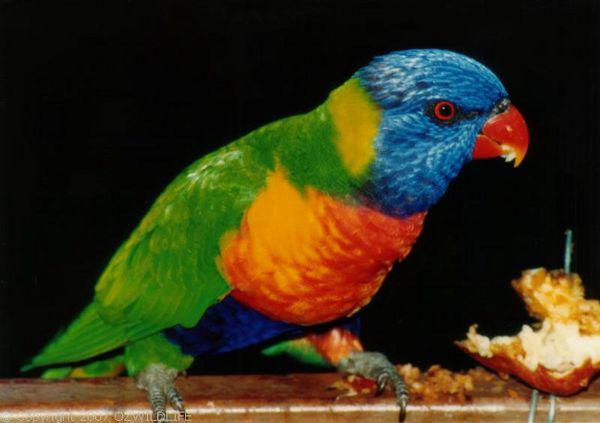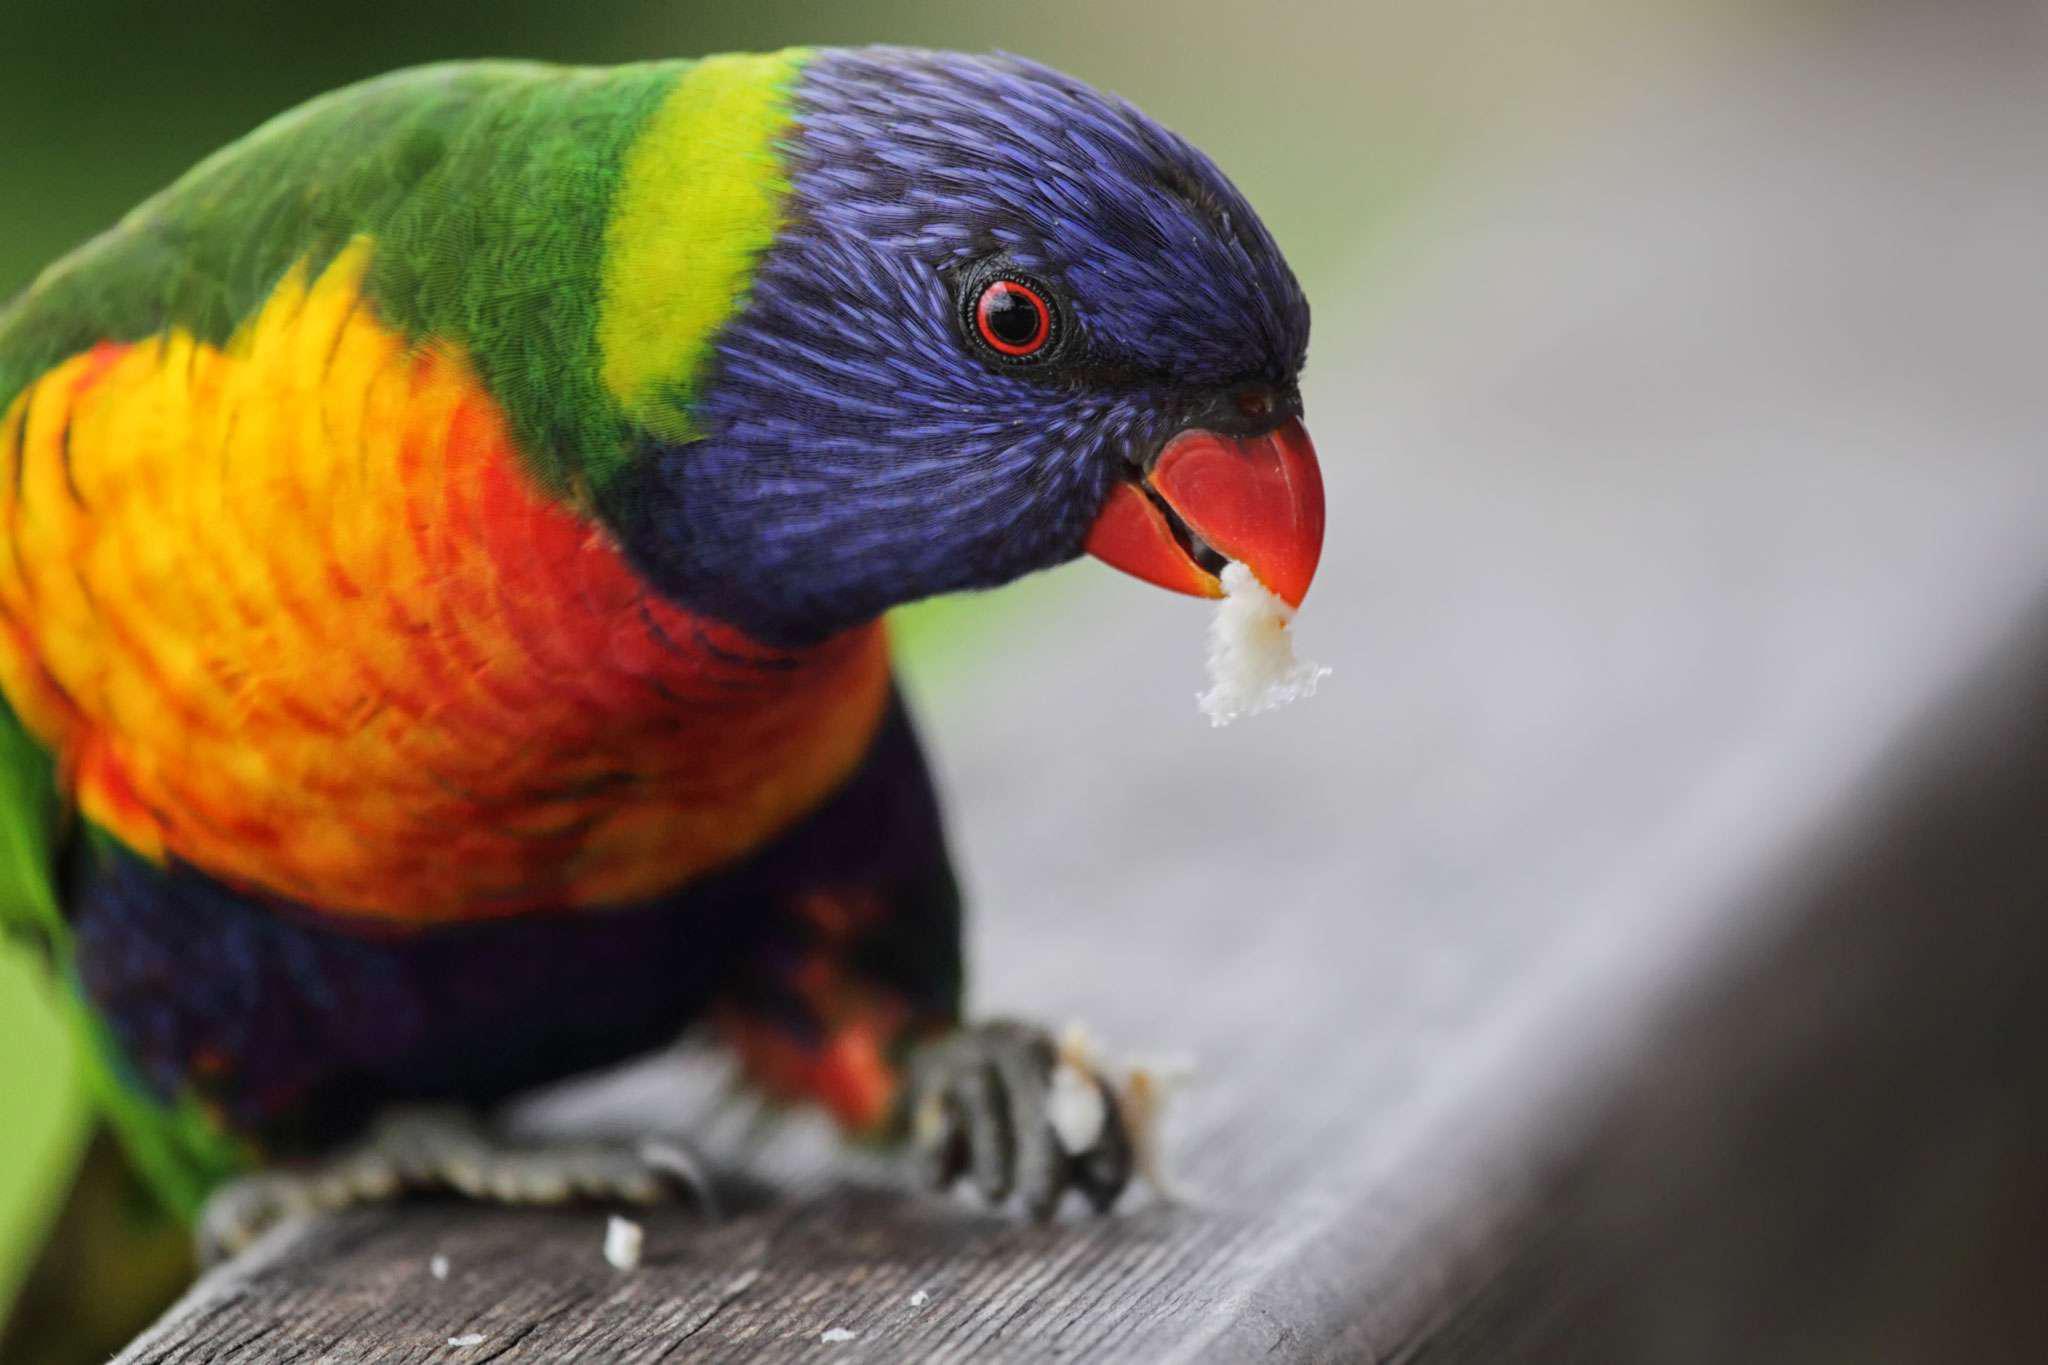The first image is the image on the left, the second image is the image on the right. Assess this claim about the two images: "There are exactly two birds in the image on the right.". Correct or not? Answer yes or no. No. 